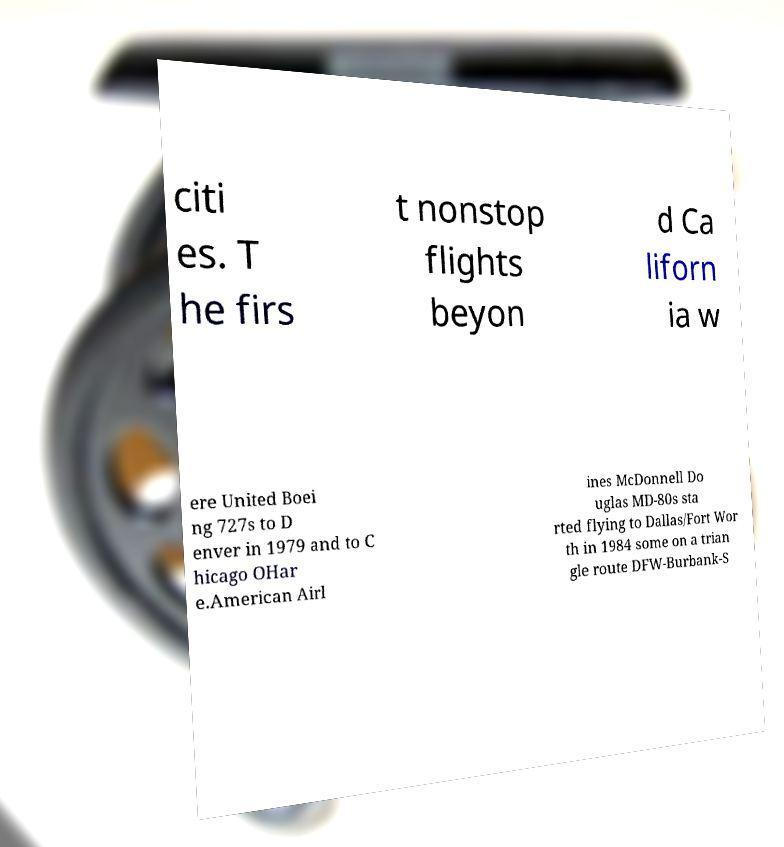Can you read and provide the text displayed in the image?This photo seems to have some interesting text. Can you extract and type it out for me? citi es. T he firs t nonstop flights beyon d Ca liforn ia w ere United Boei ng 727s to D enver in 1979 and to C hicago OHar e.American Airl ines McDonnell Do uglas MD-80s sta rted flying to Dallas/Fort Wor th in 1984 some on a trian gle route DFW-Burbank-S 